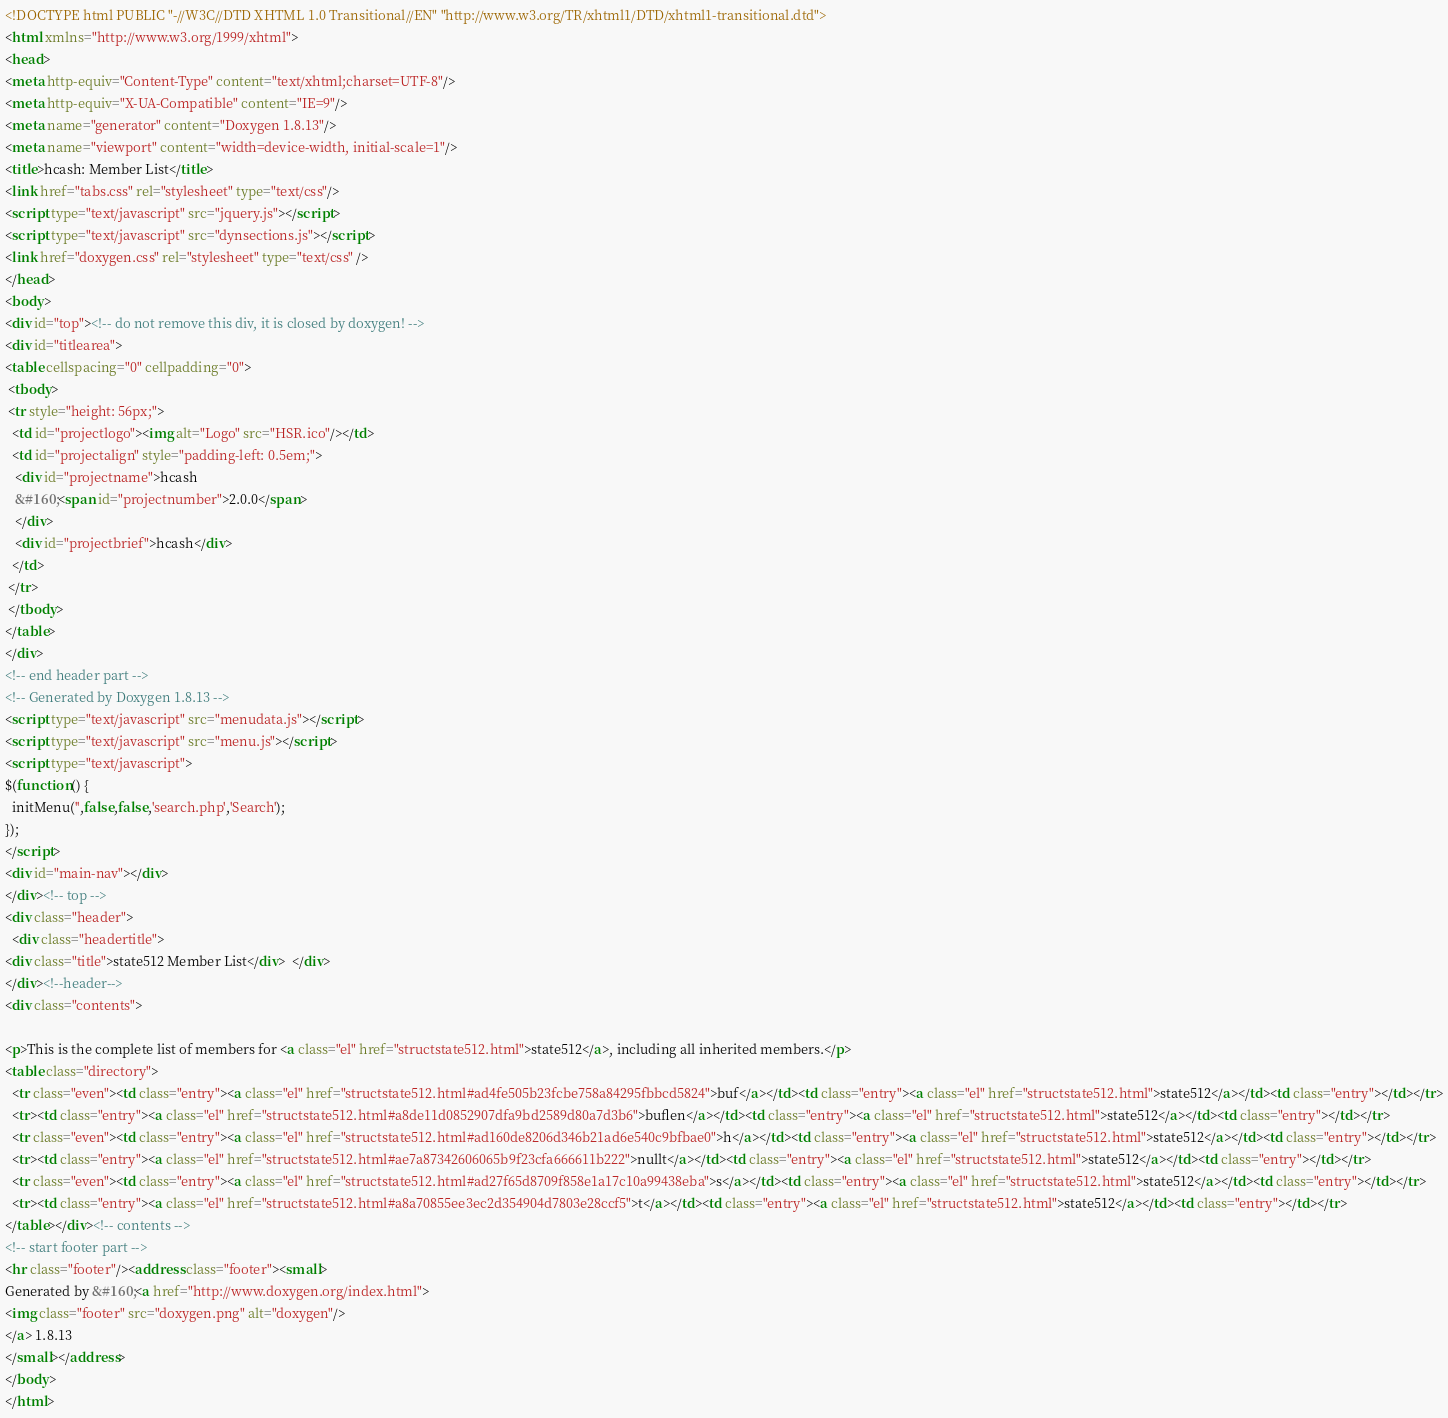<code> <loc_0><loc_0><loc_500><loc_500><_HTML_><!DOCTYPE html PUBLIC "-//W3C//DTD XHTML 1.0 Transitional//EN" "http://www.w3.org/TR/xhtml1/DTD/xhtml1-transitional.dtd">
<html xmlns="http://www.w3.org/1999/xhtml">
<head>
<meta http-equiv="Content-Type" content="text/xhtml;charset=UTF-8"/>
<meta http-equiv="X-UA-Compatible" content="IE=9"/>
<meta name="generator" content="Doxygen 1.8.13"/>
<meta name="viewport" content="width=device-width, initial-scale=1"/>
<title>hcash: Member List</title>
<link href="tabs.css" rel="stylesheet" type="text/css"/>
<script type="text/javascript" src="jquery.js"></script>
<script type="text/javascript" src="dynsections.js"></script>
<link href="doxygen.css" rel="stylesheet" type="text/css" />
</head>
<body>
<div id="top"><!-- do not remove this div, it is closed by doxygen! -->
<div id="titlearea">
<table cellspacing="0" cellpadding="0">
 <tbody>
 <tr style="height: 56px;">
  <td id="projectlogo"><img alt="Logo" src="HSR.ico"/></td>
  <td id="projectalign" style="padding-left: 0.5em;">
   <div id="projectname">hcash
   &#160;<span id="projectnumber">2.0.0</span>
   </div>
   <div id="projectbrief">hcash</div>
  </td>
 </tr>
 </tbody>
</table>
</div>
<!-- end header part -->
<!-- Generated by Doxygen 1.8.13 -->
<script type="text/javascript" src="menudata.js"></script>
<script type="text/javascript" src="menu.js"></script>
<script type="text/javascript">
$(function() {
  initMenu('',false,false,'search.php','Search');
});
</script>
<div id="main-nav"></div>
</div><!-- top -->
<div class="header">
  <div class="headertitle">
<div class="title">state512 Member List</div>  </div>
</div><!--header-->
<div class="contents">

<p>This is the complete list of members for <a class="el" href="structstate512.html">state512</a>, including all inherited members.</p>
<table class="directory">
  <tr class="even"><td class="entry"><a class="el" href="structstate512.html#ad4fe505b23fcbe758a84295fbbcd5824">buf</a></td><td class="entry"><a class="el" href="structstate512.html">state512</a></td><td class="entry"></td></tr>
  <tr><td class="entry"><a class="el" href="structstate512.html#a8de11d0852907dfa9bd2589d80a7d3b6">buflen</a></td><td class="entry"><a class="el" href="structstate512.html">state512</a></td><td class="entry"></td></tr>
  <tr class="even"><td class="entry"><a class="el" href="structstate512.html#ad160de8206d346b21ad6e540c9bfbae0">h</a></td><td class="entry"><a class="el" href="structstate512.html">state512</a></td><td class="entry"></td></tr>
  <tr><td class="entry"><a class="el" href="structstate512.html#ae7a87342606065b9f23cfa666611b222">nullt</a></td><td class="entry"><a class="el" href="structstate512.html">state512</a></td><td class="entry"></td></tr>
  <tr class="even"><td class="entry"><a class="el" href="structstate512.html#ad27f65d8709f858e1a17c10a99438eba">s</a></td><td class="entry"><a class="el" href="structstate512.html">state512</a></td><td class="entry"></td></tr>
  <tr><td class="entry"><a class="el" href="structstate512.html#a8a70855ee3ec2d354904d7803e28ccf5">t</a></td><td class="entry"><a class="el" href="structstate512.html">state512</a></td><td class="entry"></td></tr>
</table></div><!-- contents -->
<!-- start footer part -->
<hr class="footer"/><address class="footer"><small>
Generated by &#160;<a href="http://www.doxygen.org/index.html">
<img class="footer" src="doxygen.png" alt="doxygen"/>
</a> 1.8.13
</small></address>
</body>
</html>
</code> 